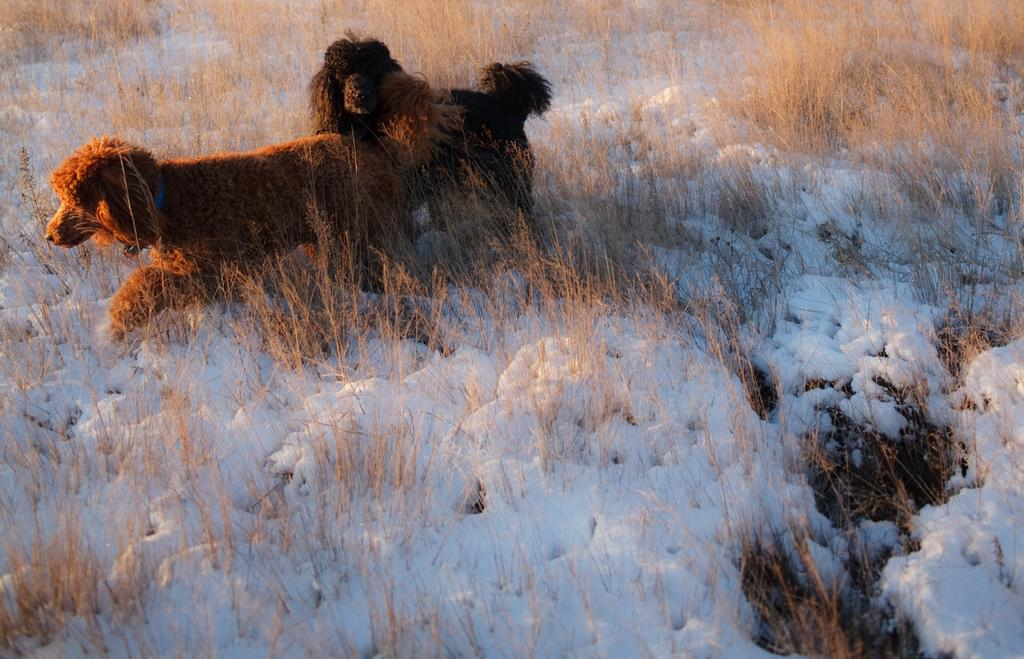How many dogs are in the image? There are two dogs in the image. What are the dogs doing in the image? The dogs are standing in the image. What type of terrain is visible in the image? There is grass and snow in the image. What key is used to unlock the history of the dogs in the image? There is no key or history of the dogs mentioned in the image; it simply shows two dogs standing on grass and snow. 